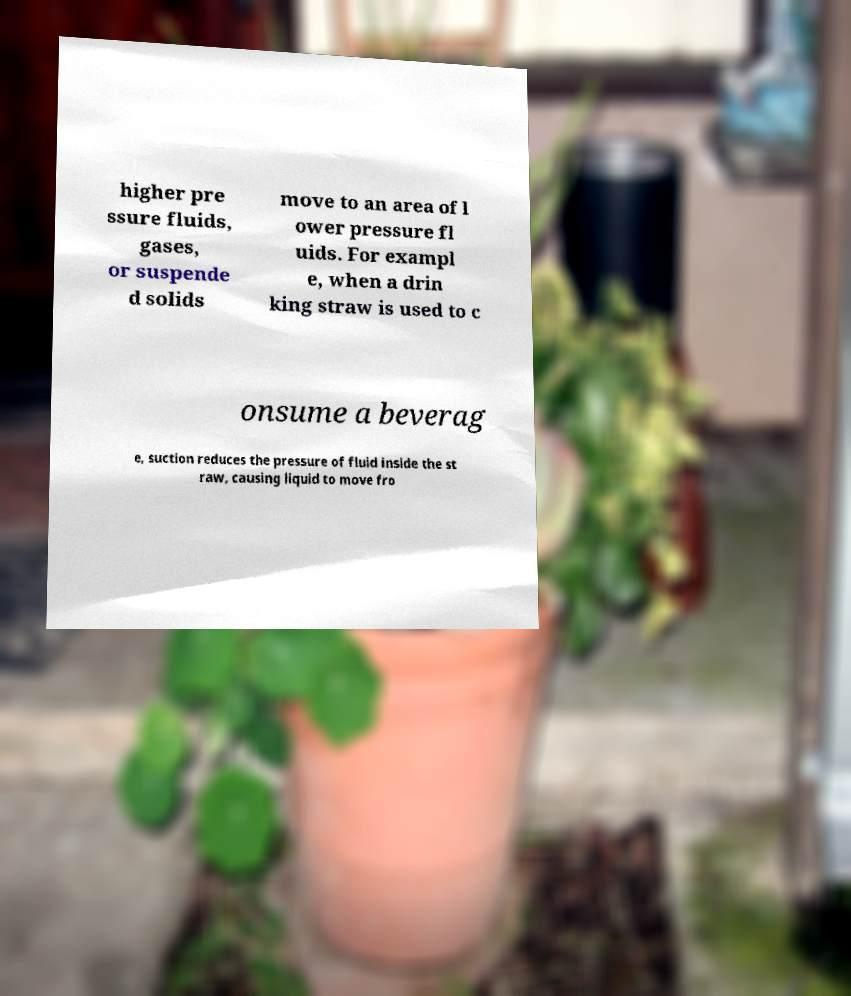Could you assist in decoding the text presented in this image and type it out clearly? higher pre ssure fluids, gases, or suspende d solids move to an area of l ower pressure fl uids. For exampl e, when a drin king straw is used to c onsume a beverag e, suction reduces the pressure of fluid inside the st raw, causing liquid to move fro 